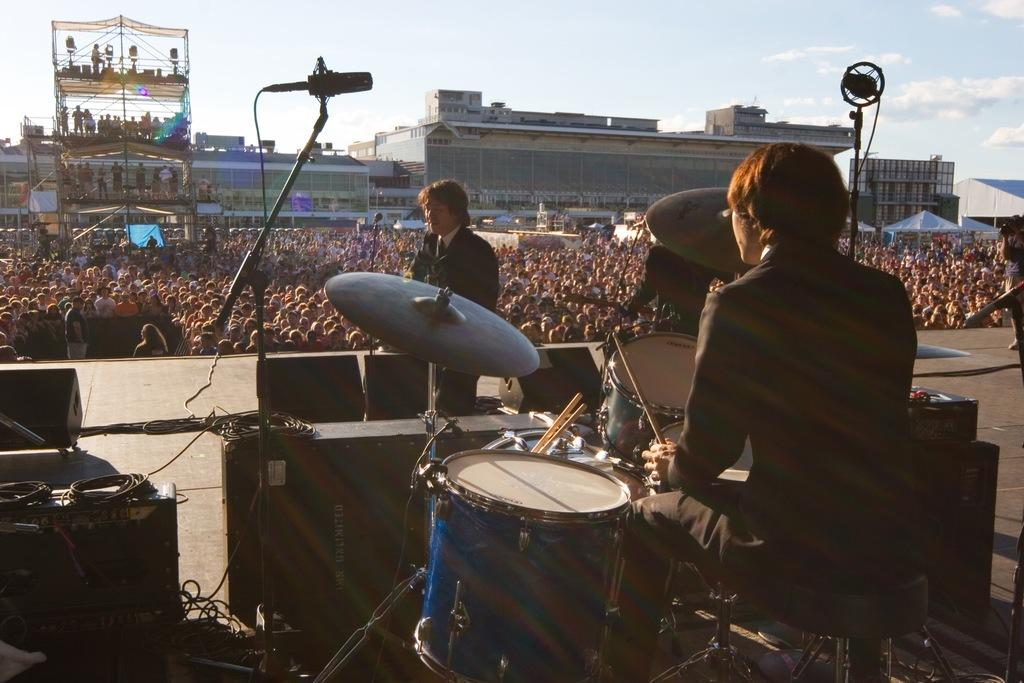What is the main activity taking place in the image? A person is playing drums in the image. Can you describe the position of the other person in relation to the drummer? There is another person standing in front of the drummer. How many people are observing the performance? There are many people watching the performance. What can be seen in the distance behind the performers? There are buildings visible in the background. What type of crate is being used to support the drummer's muscles during the performance? There is no crate or mention of muscle support in the image; the drummer is simply playing drums. 